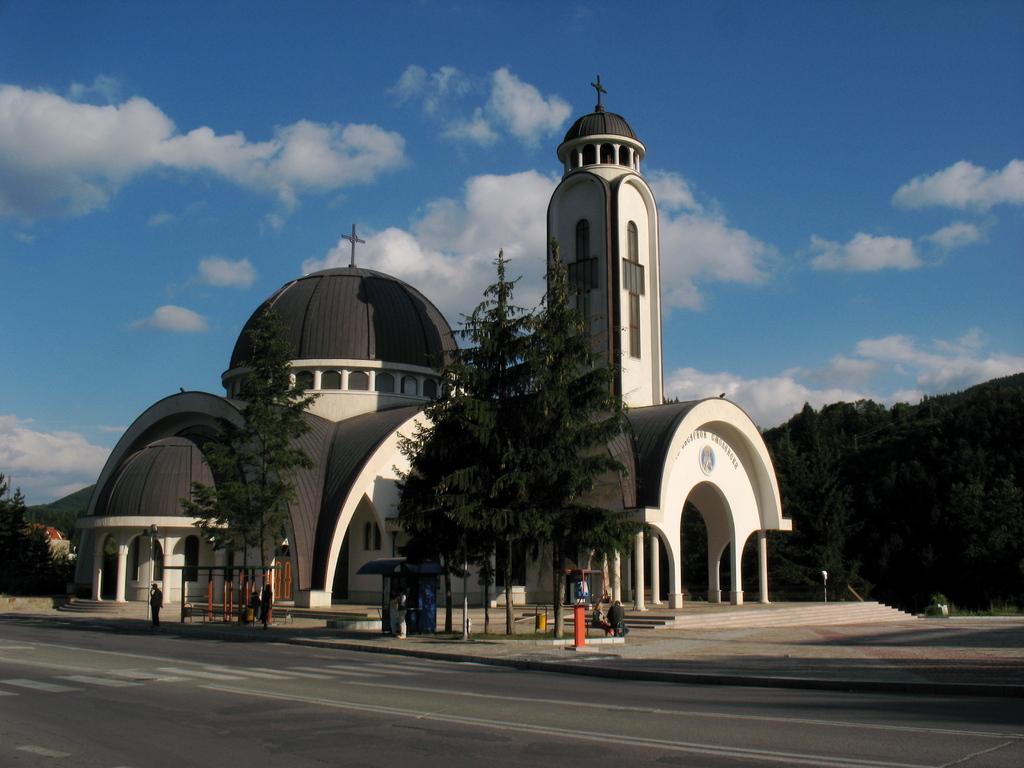Please provide a concise description of this image. In this image we can see a building. In front of the building we can see trees, poles, persons and a booth. There are two persons sitting on a bench. Behind the building we can see a group of trees. At the top we can see the sky. 